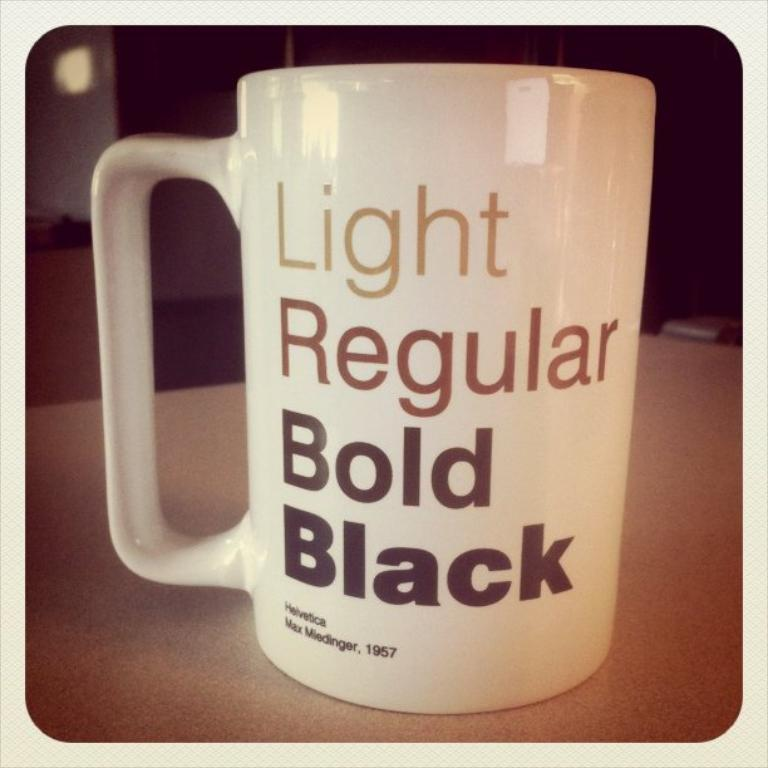<image>
Share a concise interpretation of the image provided. A coffeemug says Light, Regular, Bold and Black on it. 